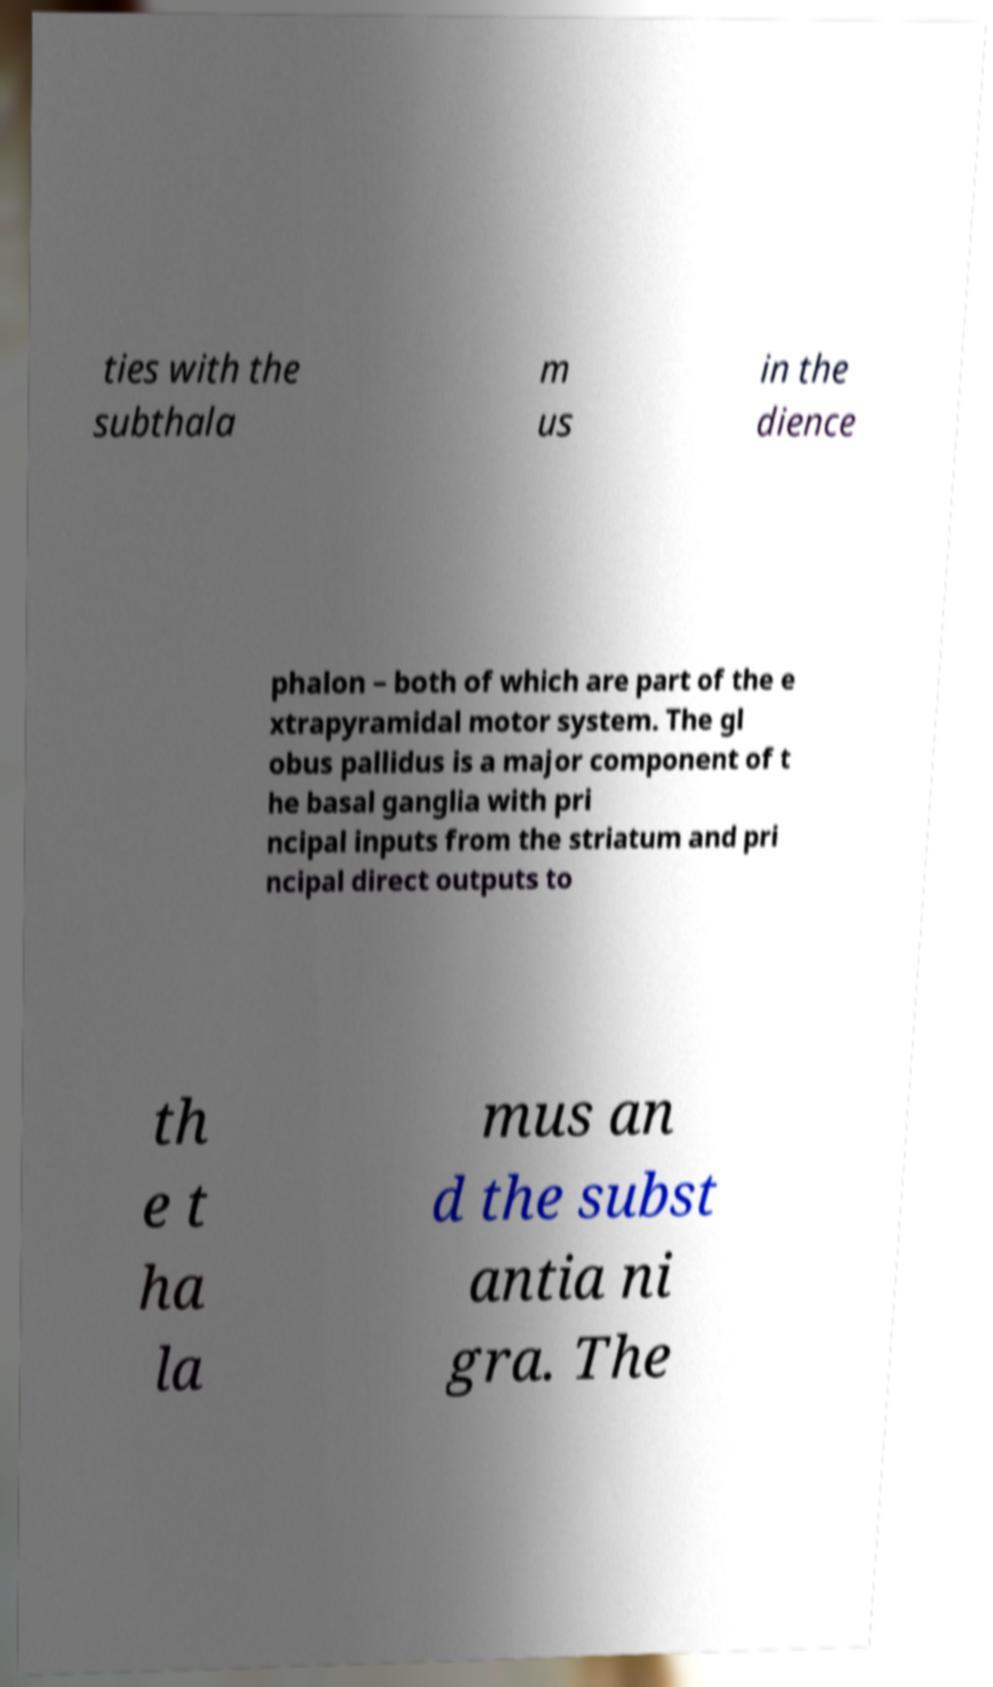Please identify and transcribe the text found in this image. ties with the subthala m us in the dience phalon – both of which are part of the e xtrapyramidal motor system. The gl obus pallidus is a major component of t he basal ganglia with pri ncipal inputs from the striatum and pri ncipal direct outputs to th e t ha la mus an d the subst antia ni gra. The 